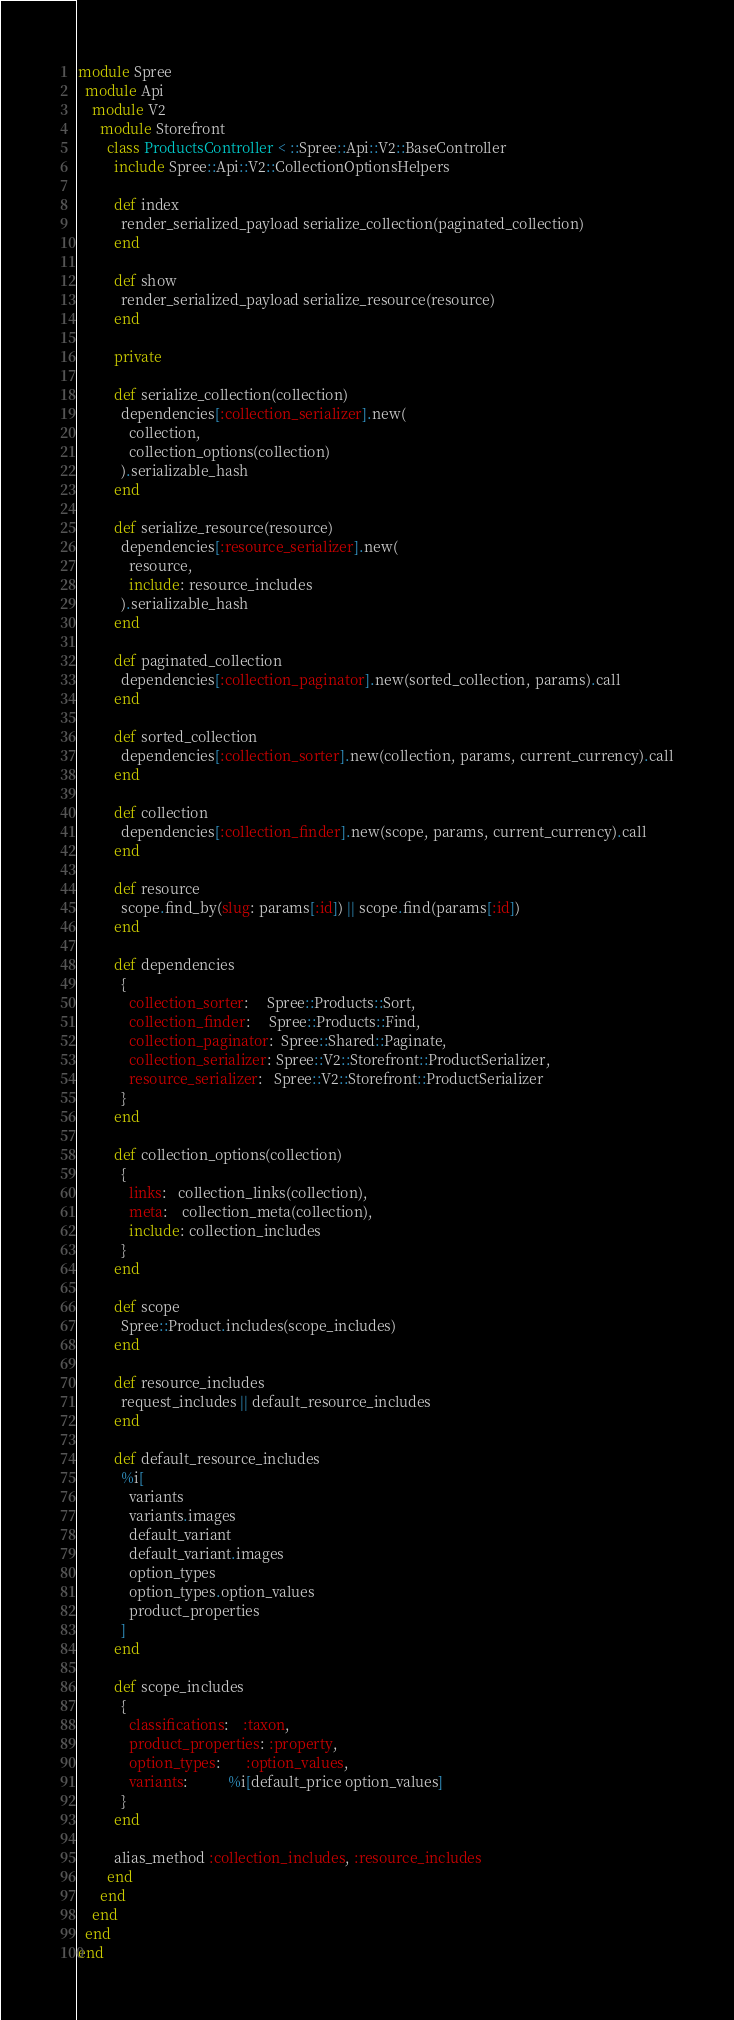<code> <loc_0><loc_0><loc_500><loc_500><_Ruby_>module Spree
  module Api
    module V2
      module Storefront
        class ProductsController < ::Spree::Api::V2::BaseController
          include Spree::Api::V2::CollectionOptionsHelpers

          def index
            render_serialized_payload serialize_collection(paginated_collection)
          end

          def show
            render_serialized_payload serialize_resource(resource)
          end

          private

          def serialize_collection(collection)
            dependencies[:collection_serializer].new(
              collection,
              collection_options(collection)
            ).serializable_hash
          end

          def serialize_resource(resource)
            dependencies[:resource_serializer].new(
              resource,
              include: resource_includes
            ).serializable_hash
          end

          def paginated_collection
            dependencies[:collection_paginator].new(sorted_collection, params).call
          end

          def sorted_collection
            dependencies[:collection_sorter].new(collection, params, current_currency).call
          end

          def collection
            dependencies[:collection_finder].new(scope, params, current_currency).call
          end

          def resource
            scope.find_by(slug: params[:id]) || scope.find(params[:id])
          end

          def dependencies
            {
              collection_sorter:     Spree::Products::Sort,
              collection_finder:     Spree::Products::Find,
              collection_paginator:  Spree::Shared::Paginate,
              collection_serializer: Spree::V2::Storefront::ProductSerializer,
              resource_serializer:   Spree::V2::Storefront::ProductSerializer
            }
          end

          def collection_options(collection)
            {
              links:   collection_links(collection),
              meta:    collection_meta(collection),
              include: collection_includes
            }
          end

          def scope
            Spree::Product.includes(scope_includes)
          end

          def resource_includes
            request_includes || default_resource_includes
          end

          def default_resource_includes
            %i[
              variants
              variants.images
              default_variant
              default_variant.images
              option_types
              option_types.option_values
              product_properties
            ]
          end

          def scope_includes
            {
              classifications:    :taxon,
              product_properties: :property,
              option_types:       :option_values,
              variants:           %i[default_price option_values]
            }
          end

          alias_method :collection_includes, :resource_includes
        end
      end
    end
  end
end
</code> 